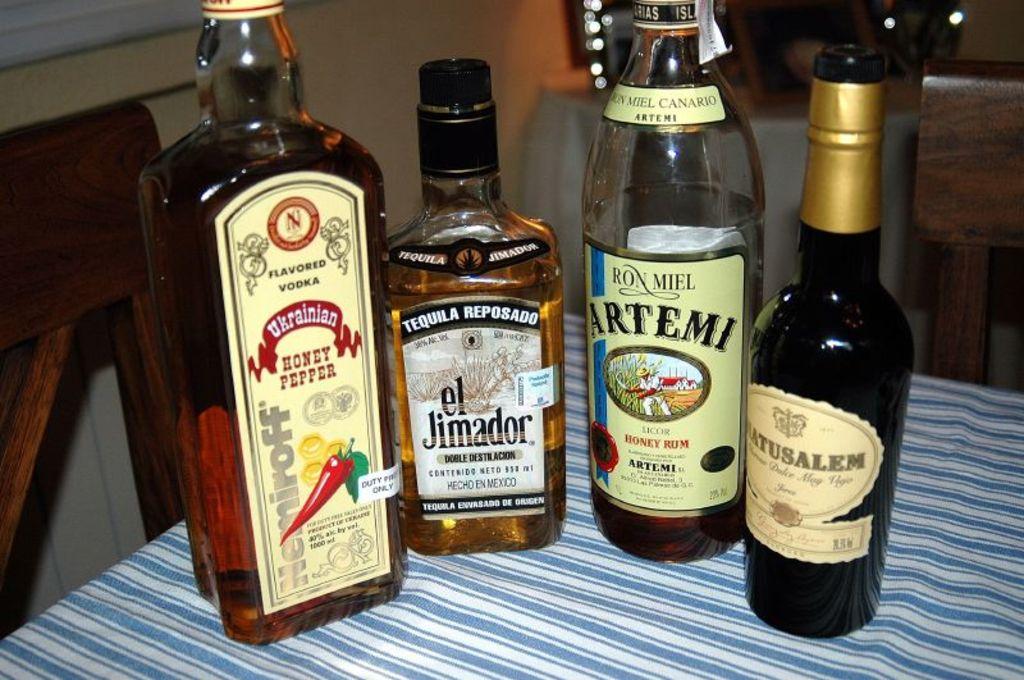What flavor is the ukrainian vodka?
Provide a short and direct response. Honey pepper. 